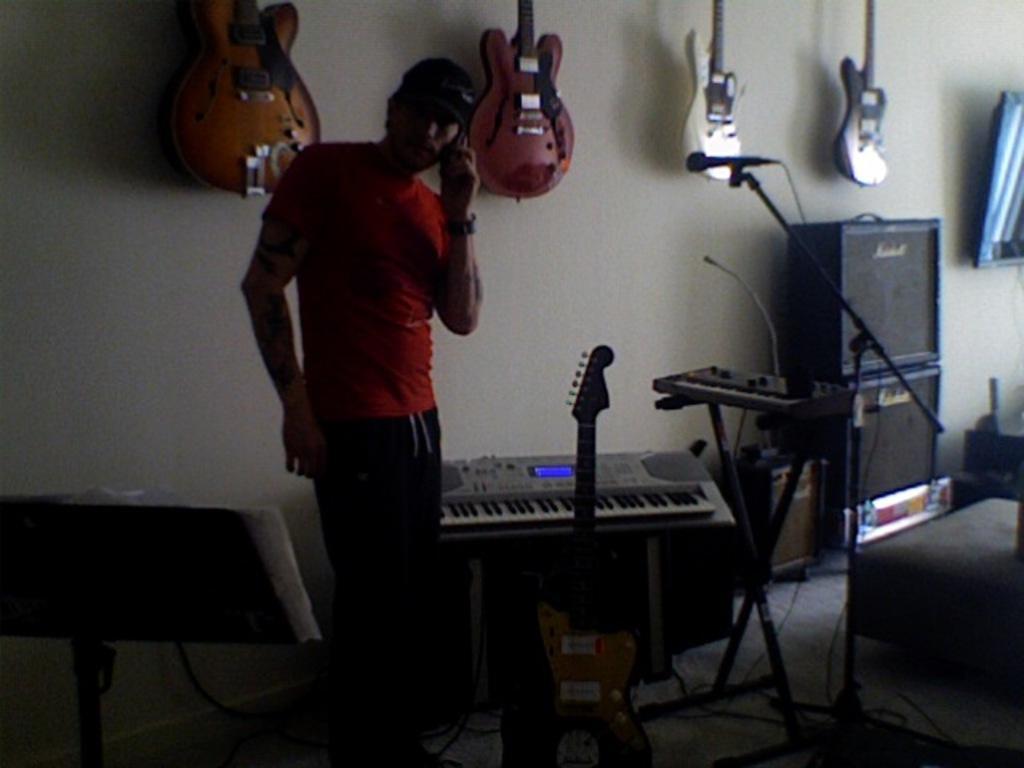Can you describe this image briefly? This picture is of inside the room. On the right there are two speakers placed one above the another and there is a microphone attached to the stand and placed on the ground, beside that there is a musical keyboard placed on the stand. In the center there is a Guitar and a musical instrument placed on the ground and there is a Man wearing a red color t-shirt, standing and seems to be talking on mobile phone. On the left there is a stand. In the background we can see the Guitars hanging on the wall. 